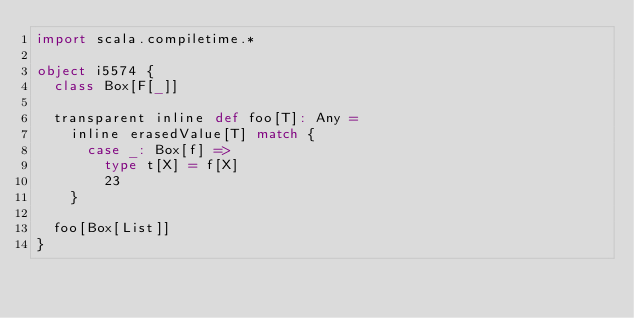Convert code to text. <code><loc_0><loc_0><loc_500><loc_500><_Scala_>import scala.compiletime.*

object i5574 {
  class Box[F[_]]

  transparent inline def foo[T]: Any =
    inline erasedValue[T] match {
      case _: Box[f] =>
        type t[X] = f[X]
        23
    }

  foo[Box[List]]
}
</code> 